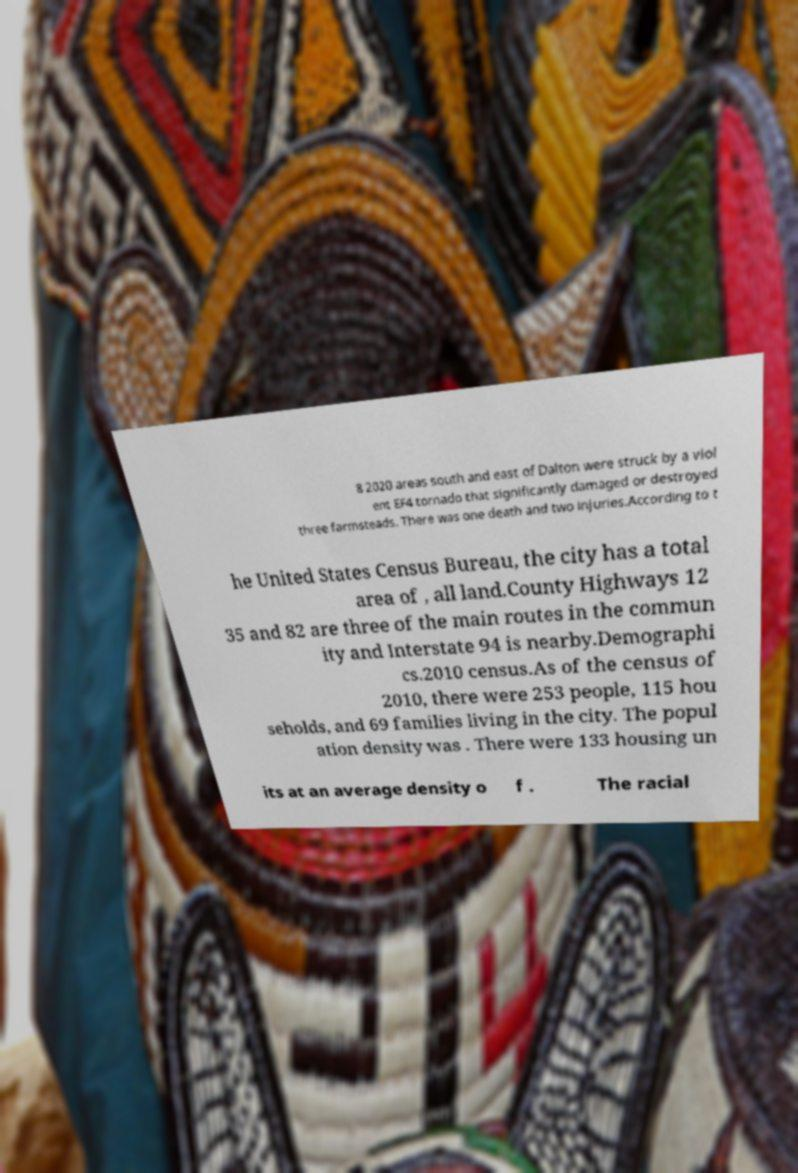There's text embedded in this image that I need extracted. Can you transcribe it verbatim? 8 2020 areas south and east of Dalton were struck by a viol ent EF4 tornado that significantly damaged or destroyed three farmsteads. There was one death and two injuries.According to t he United States Census Bureau, the city has a total area of , all land.County Highways 12 35 and 82 are three of the main routes in the commun ity and Interstate 94 is nearby.Demographi cs.2010 census.As of the census of 2010, there were 253 people, 115 hou seholds, and 69 families living in the city. The popul ation density was . There were 133 housing un its at an average density o f . The racial 